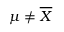Convert formula to latex. <formula><loc_0><loc_0><loc_500><loc_500>\mu \neq { \overline { X } }</formula> 